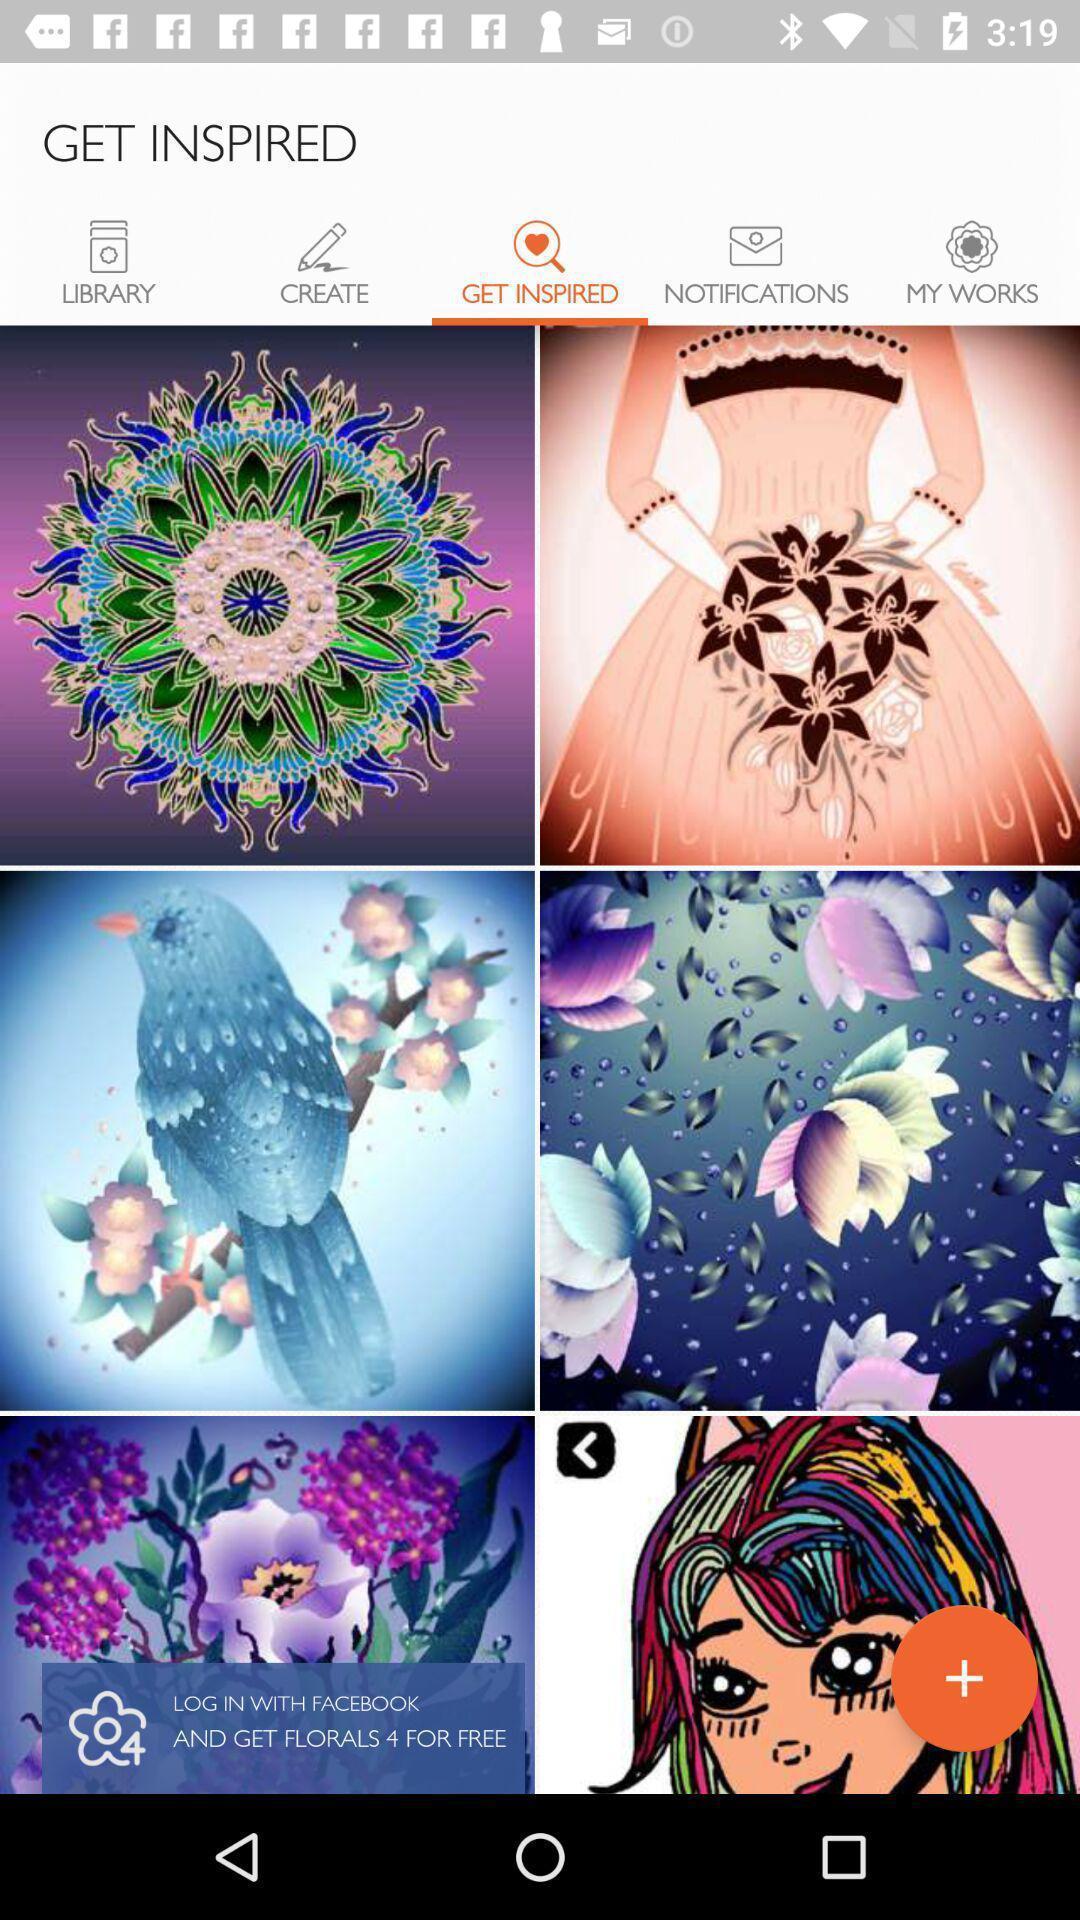Provide a description of this screenshot. Result for get inspired in an coloring book app. 